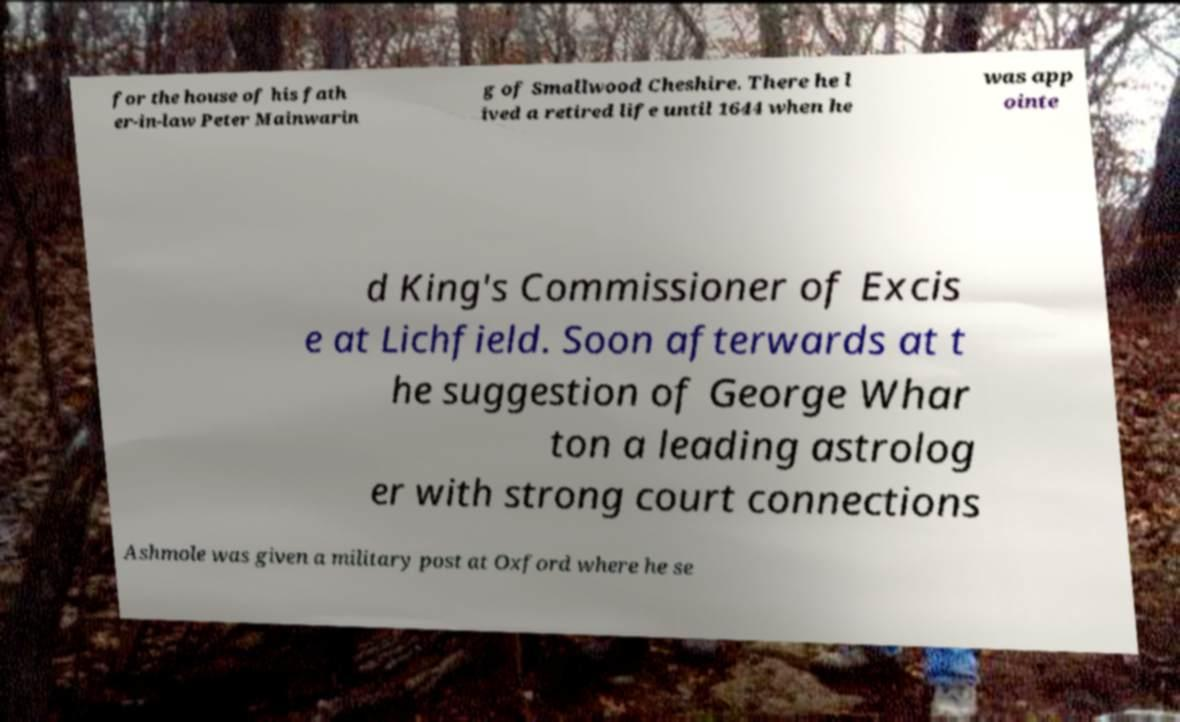For documentation purposes, I need the text within this image transcribed. Could you provide that? for the house of his fath er-in-law Peter Mainwarin g of Smallwood Cheshire. There he l ived a retired life until 1644 when he was app ointe d King's Commissioner of Excis e at Lichfield. Soon afterwards at t he suggestion of George Whar ton a leading astrolog er with strong court connections Ashmole was given a military post at Oxford where he se 